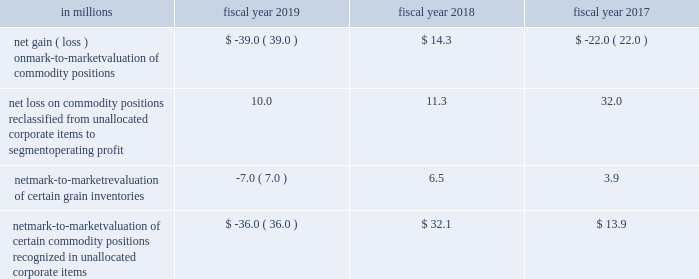Commodities purchased for use in our supply chain .
We manage our exposures through a combination of purchase orders , long-term contracts with suppliers , exchange-traded futures and options , and over-the-counter options and swaps .
We offset our exposures based on current and projected market conditions and generally seek to acquire the inputs at as close to our planned cost as possible .
We use derivatives to manage our exposure to changes in commodity prices .
We do not perform the assessments required to achieve hedge accounting for commodity derivative positions .
Accordingly , the changes in the values of these derivatives are recorded currently in cost of sales in our consolidated statements of earnings .
Although we do not meet the criteria for cash flow hedge accounting , we believe that these instruments are effective in achieving our objective of providing certainty in the future price of commodities purchased for use in our supply chain .
Accordingly , for purposes of measuring segment operating performance these gains and losses are reported in unallocated corporate items outside of segment operating results until such time that the exposure we are managing affects earnings .
At that time we reclassify the gain or loss from unallocated corporate items to segment operating profit , allowing our operating segments to realize the economic effects of the derivative without experiencing any resulting mark-to-market volatility , which remains in unallocated corporate items .
Unallocated corporate items for fiscal 2019 , 2018 and 2017 included: .
Net mark-to-market valuation of certain commodity positions recognized in unallocated corporate items $ ( 36.0 ) $ 32.1 $ 13.9 as of may 26 , 2019 , the net notional value of commodity derivatives was $ 312.5 million , of which $ 242.9 million related to agricultural inputs and $ 69.6 million related to energy inputs .
These contracts relate to inputs that generally will be utilized within the next 12 months .
Interest rate risk we are exposed to interest rate volatility with regard to future issuances of fixed-rate debt , and existing and future issuances of floating-rate debt .
Primary exposures include u.s .
Treasury rates , libor , euribor , and commercial paper rates in the united states and europe .
We use interest rate swaps , forward-starting interest rate swaps , and treasury locks to hedge our exposure to interest rate changes , to reduce the volatility of our financing costs , and to achieve a desired proportion of fixed rate versus floating-rate debt , based on current and projected market conditions .
Generally under these swaps , we agree with a counterparty to exchange the difference between fixed-rate and floating-rate interest amounts based on an agreed upon notional principal amount .
Floating interest rate exposures 2014 floating-to-fixed interest rate swaps are accounted for as cash flow hedges , as are all hedges of forecasted issuances of debt .
Effectiveness is assessed based on either the perfectly effective hypothetical derivative method or changes in the present value of interest payments on the underlying debt .
Effective gains and losses deferred to aoci are reclassified into earnings over the life of the associated debt .
Ineffective gains and losses are recorded as net interest .
The amount of hedge ineffectiveness was less than $ 1 million in fiscal 2019 , a $ 2.6 million loss in fiscal 2018 , and less than $ 1 million in fiscal 2017 .
Fixed interest rate exposures 2014 fixed-to-floating interest rate swaps are accounted for as fair value hedges with effectiveness assessed based on changes in the fair value of the underlying debt and derivatives , using .
What is the net change in netmark-to-marketvaluation of certain commodity position from 2018 to 2019 as presented in the table? 
Computations: (-36.0 - 32.1)
Answer: -68.1. 